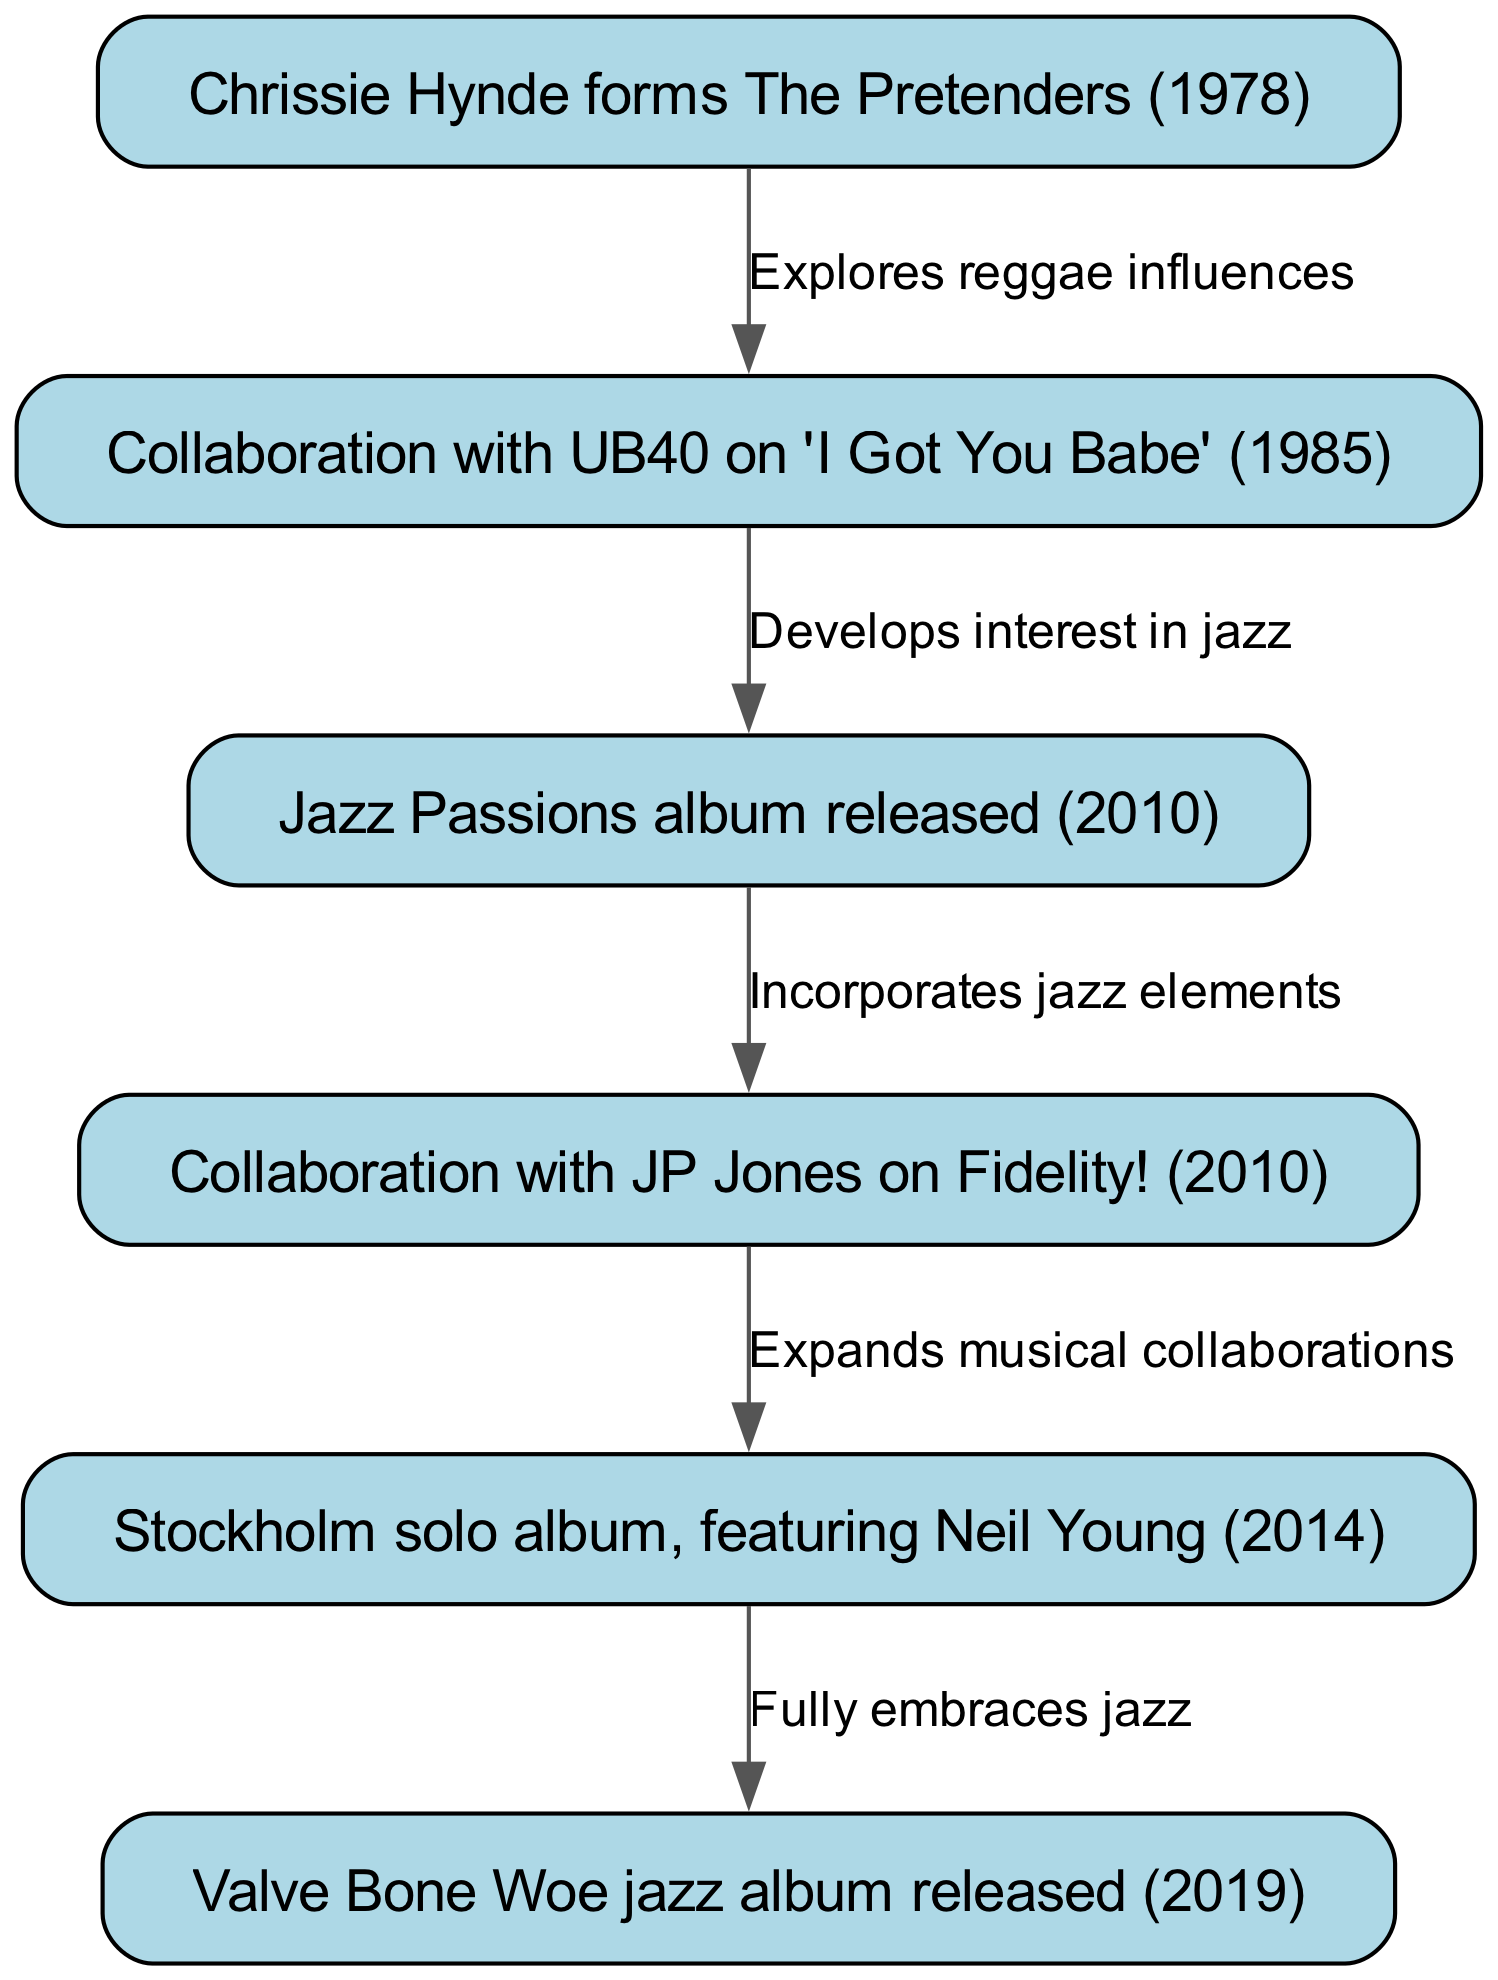What year did Chrissie Hynde form The Pretenders? The diagram shows the node "Chrissie Hynde forms The Pretenders", which is dated 1978. Therefore, we can directly extract the year from this information.
Answer: 1978 What is the title of the jazz album released in 2019? The diagram includes the node “Valve Bone Woe jazz album released (2019)”, indicating the specific title and release year. Hence, the answer can be found directly within this node.
Answer: Valve Bone Woe How many collaborations are shown in the diagram? By counting the edges that represent collaborations, we see there are 4 distinct edges connecting different nodes, indicating the number of collaborations made throughout the timeline.
Answer: 4 What influence did Chrissie Hynde explore in the collaboration with UB40? The edge connecting "Collaboration with UB40 on 'I Got You Babe' (1985)" to its preceding node states "Explores reggae influences", revealing the musical influence from the collaboration.
Answer: reggae influences What musical genre did Chrissie Hynde fully embrace by 2019? The flow from "Stockholm solo album, featuring Neil Young (2014)" to "Valve Bone Woe jazz album released (2019)" indicates a progression where the edge describes the transition to fully embracing jazz music. Hence, the answer can be directly obtained from this connection.
Answer: jazz Which album marked the start of Chrissie Hynde’s interest in jazz? Following the edges in the diagram, "Jazz Passions album released (2010)" is linked to "Collaboration with UB40 on 'I Got You Babe' (1985)" via "Develops interest in jazz". This shows that the interest in jazz began with the release of this album.
Answer: Jazz Passions What was the relationship between "Jazz Passions" and "Fidelity!"? The arrow from "Jazz Passions album released (2010)" to "Collaboration with JP Jones on Fidelity! (2010)" shows an incorporation of jazz elements between these two nodes, detailing an important linkage in Chrissie Hynde’s trajectory.
Answer: Incorporates jazz elements How did Chrissie Hynde's collaborations evolve from 2010 to 2014? The edges suggest a development where after “Jazz Passions” led to “Fidelity!”, and it later connects to the “Stockholm solo album, featuring Neil Young (2014)”, indicating an expansion of Musical collaborations in this timeframe. This reasoning showcases the transition and growth in her artistic output.
Answer: Expands musical collaborations 